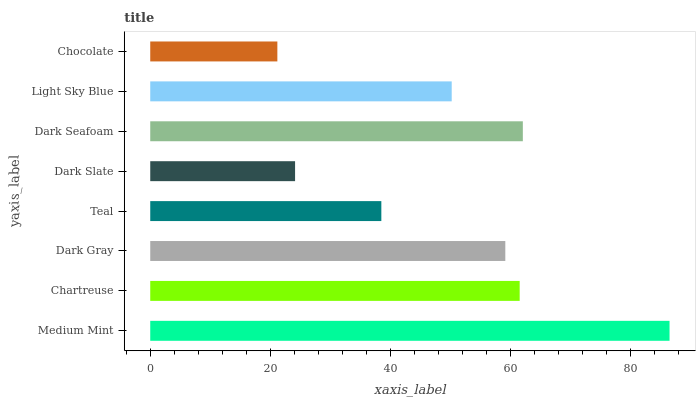Is Chocolate the minimum?
Answer yes or no. Yes. Is Medium Mint the maximum?
Answer yes or no. Yes. Is Chartreuse the minimum?
Answer yes or no. No. Is Chartreuse the maximum?
Answer yes or no. No. Is Medium Mint greater than Chartreuse?
Answer yes or no. Yes. Is Chartreuse less than Medium Mint?
Answer yes or no. Yes. Is Chartreuse greater than Medium Mint?
Answer yes or no. No. Is Medium Mint less than Chartreuse?
Answer yes or no. No. Is Dark Gray the high median?
Answer yes or no. Yes. Is Light Sky Blue the low median?
Answer yes or no. Yes. Is Dark Slate the high median?
Answer yes or no. No. Is Chartreuse the low median?
Answer yes or no. No. 